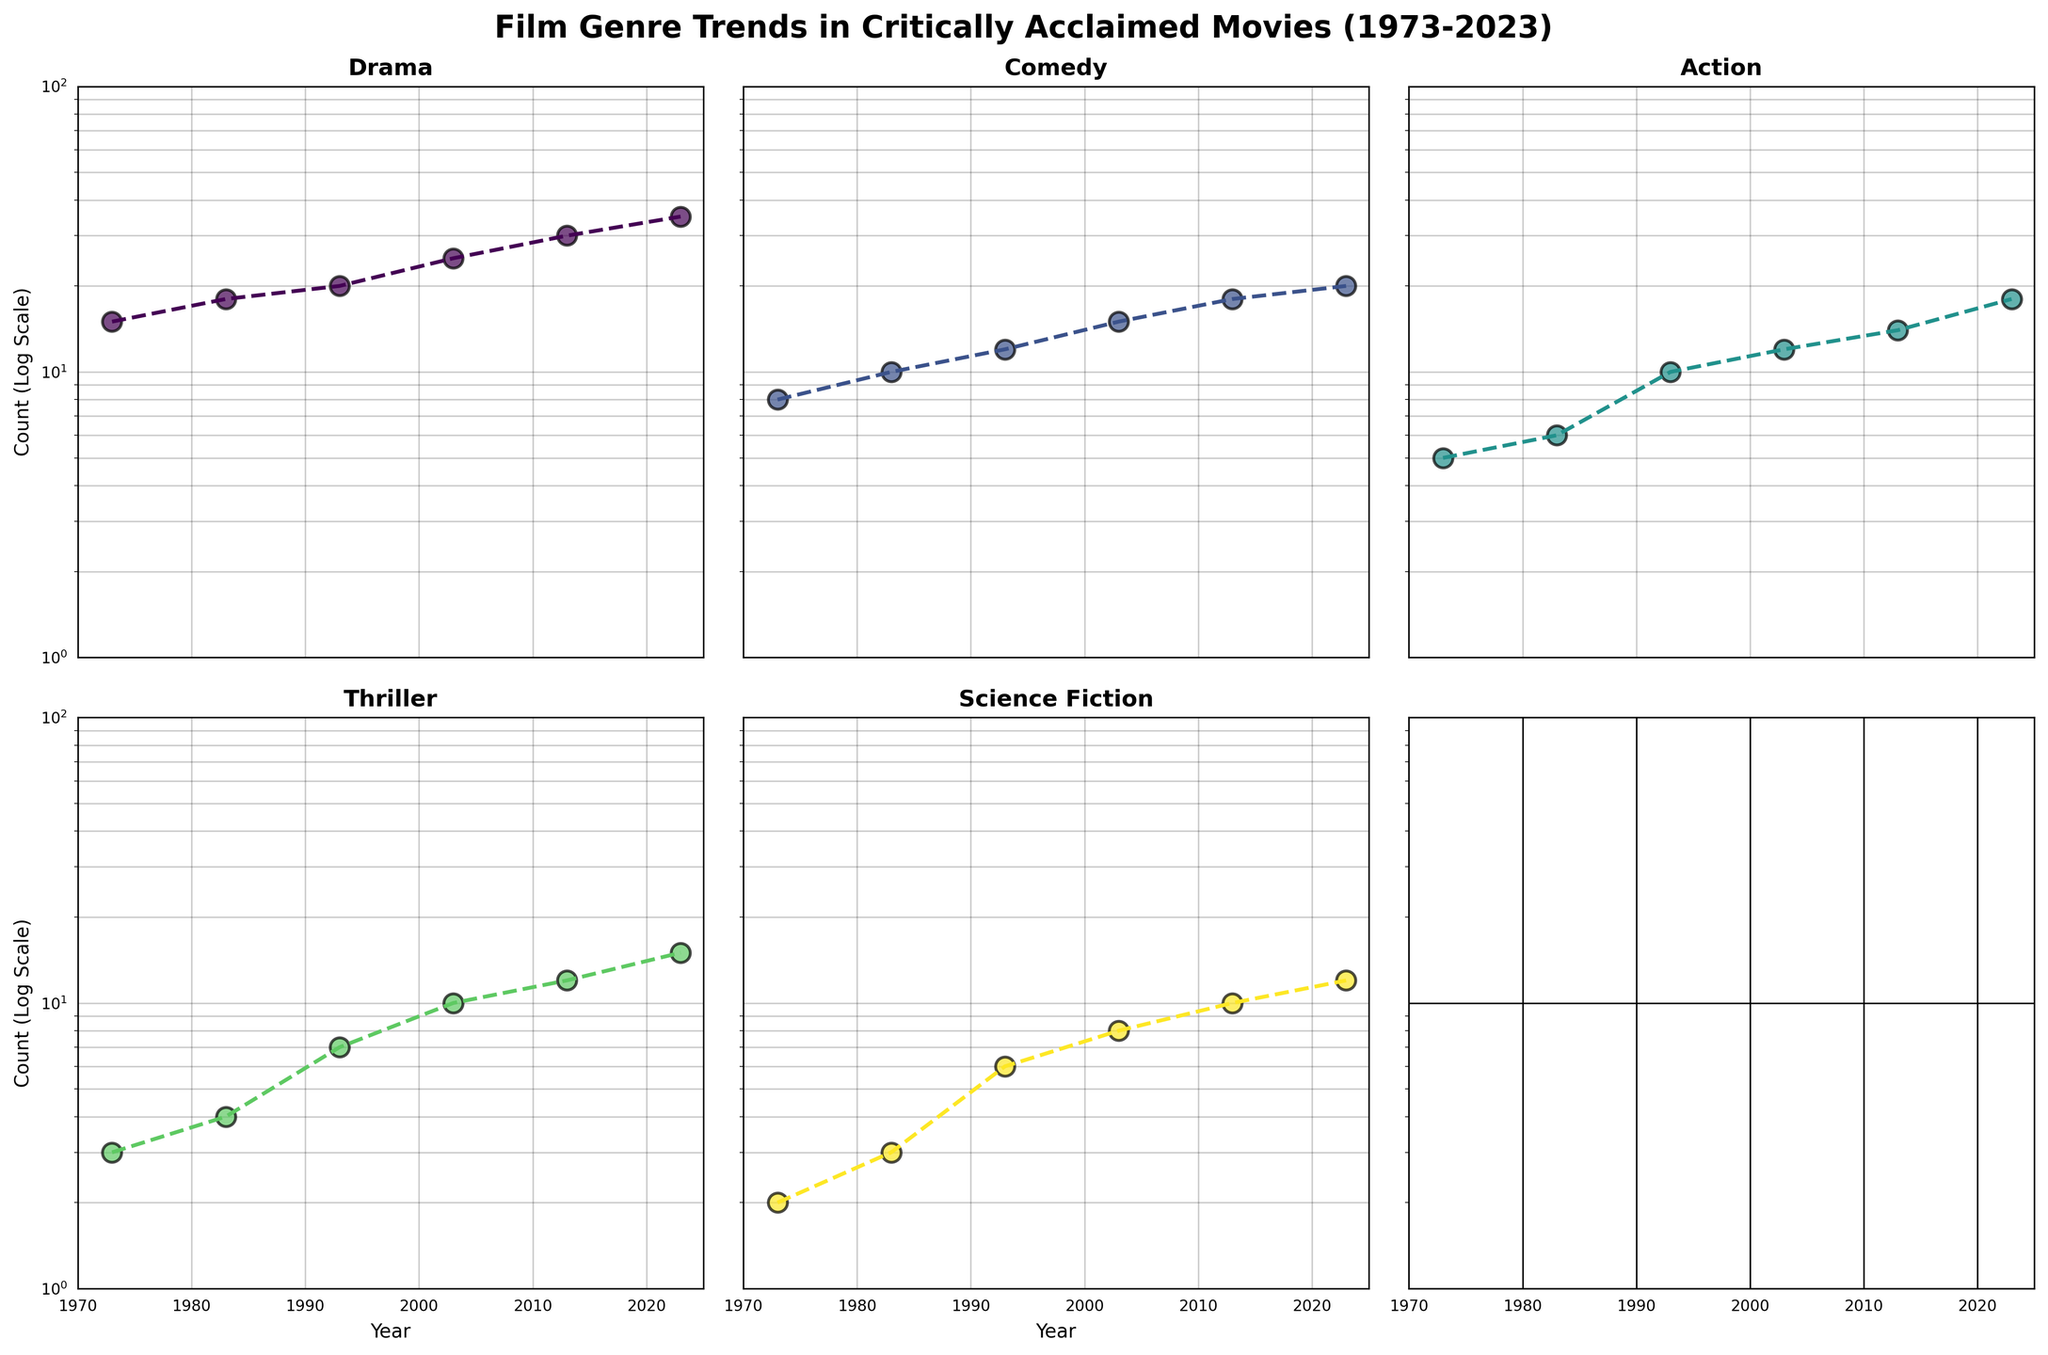What is the total number of genres shown in the figure? To find the total number of genres, count the unique genres displayed in the subplot titles.
Answer: 5 Which genre shows the highest count in the year 2023? Look for the genre with the largest data point in the year 2023 on the y-axis.
Answer: Drama What are the genres whose counts are consistently increasing every decade? Observe each genre's plot and note if each year's count is higher than the previous decade’s.
Answer: All genres (Drama, Comedy, Action, Thriller, Science Fiction) What is the ratio of the count of Drama to Comedy in the year 2003? Locate the data points for Drama and Comedy in 2003 and compute the ratio: 25 (Drama) / 15 (Comedy).
Answer: 5/3 or 1.67 Which genre experienced the largest relative increase from 2013 to 2023? Calculate the relative increase for each genre using ((Count in 2023 - Count in 2013) / Count in 2013) and identify the largest.
Answer: Action How do the counts for Science Fiction vary across the five decades? Examine the Science Fiction plot and note the counts for each year: 1973, 1983, 1993, 2003, 2013, 2023 as labeled in the x-axis.
Answer: 2, 3, 6, 8, 10, 12 Which two genres had overlapping counts in any decade? Compare the counts of different genres in each decade carefully.
Answer: Thriller and Science Fiction in 1973 (both 2) How does the count of Comedy in 1993 compare to Action in the same year? Identify the count of Comedy and Action in 1993 and compare them numerically. Comedy has 12 and Action has 10.
Answer: Comedy > Action What is the percentage increase in the count of Thriller from 1973 to 2023? Calculate the percentage increase using the formula: ((Count in 2023 - Count in 1973) / Count in 1973) * 100: ((15 - 3) / 3) * 100.
Answer: 400% What pattern do you notice in the counts of Action movies from 1973 to 2023? Observe the progression of Action movie counts by decade, noting any consistent changes or trends over time.
Answer: Increasing trend 